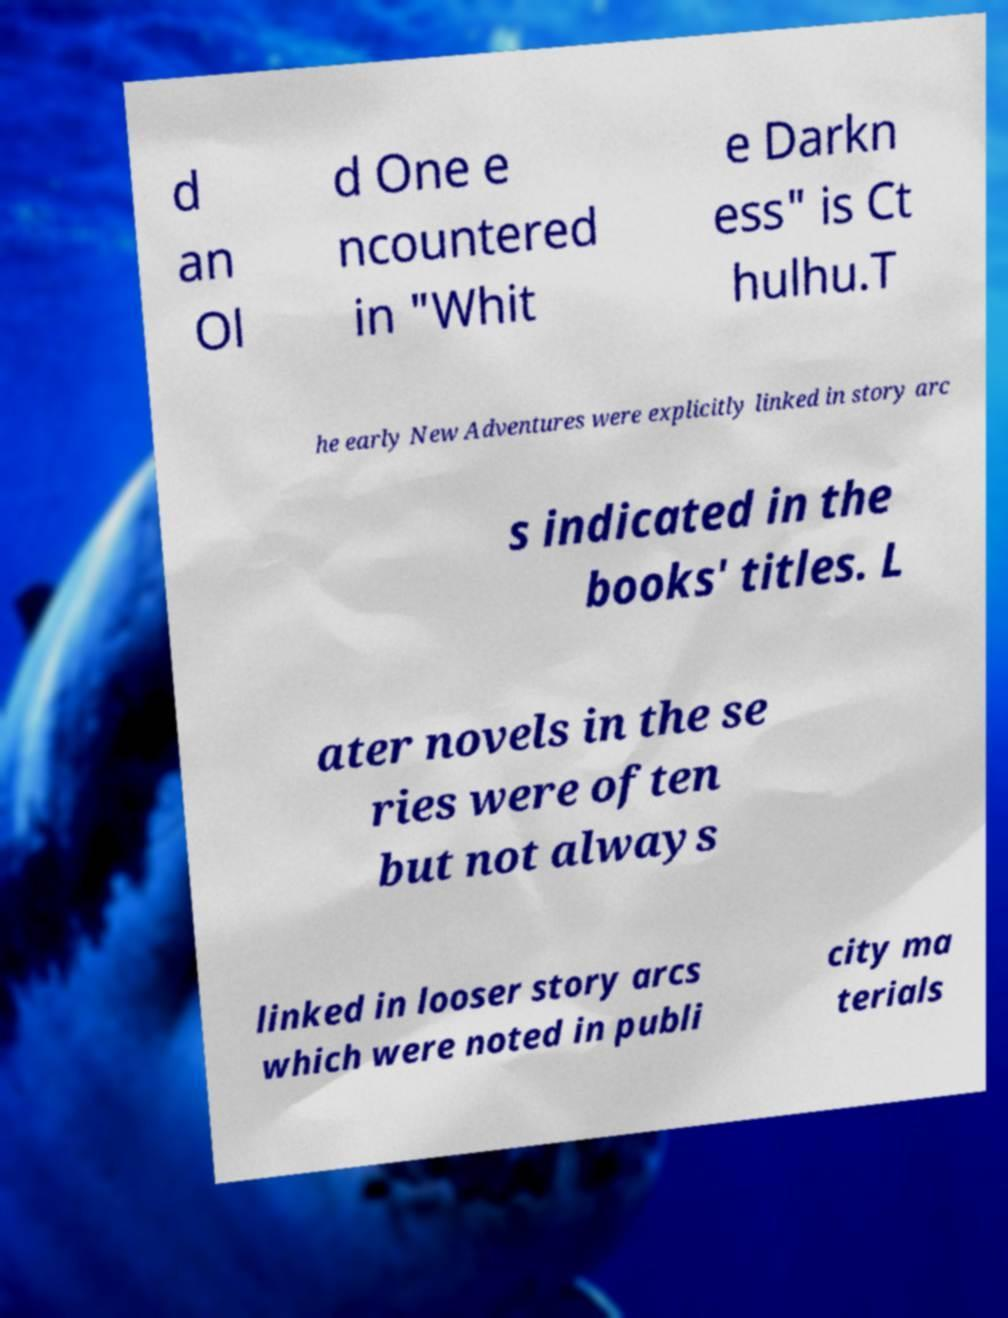Could you assist in decoding the text presented in this image and type it out clearly? d an Ol d One e ncountered in "Whit e Darkn ess" is Ct hulhu.T he early New Adventures were explicitly linked in story arc s indicated in the books' titles. L ater novels in the se ries were often but not always linked in looser story arcs which were noted in publi city ma terials 